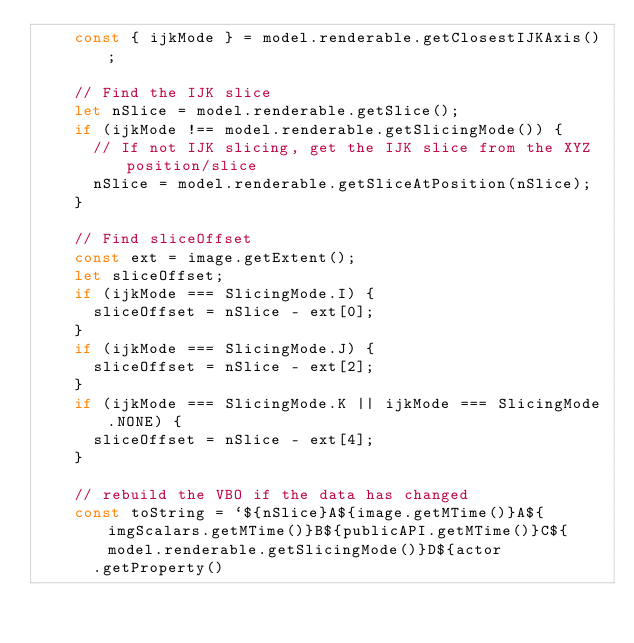<code> <loc_0><loc_0><loc_500><loc_500><_JavaScript_>    const { ijkMode } = model.renderable.getClosestIJKAxis();

    // Find the IJK slice
    let nSlice = model.renderable.getSlice();
    if (ijkMode !== model.renderable.getSlicingMode()) {
      // If not IJK slicing, get the IJK slice from the XYZ position/slice
      nSlice = model.renderable.getSliceAtPosition(nSlice);
    }

    // Find sliceOffset
    const ext = image.getExtent();
    let sliceOffset;
    if (ijkMode === SlicingMode.I) {
      sliceOffset = nSlice - ext[0];
    }
    if (ijkMode === SlicingMode.J) {
      sliceOffset = nSlice - ext[2];
    }
    if (ijkMode === SlicingMode.K || ijkMode === SlicingMode.NONE) {
      sliceOffset = nSlice - ext[4];
    }

    // rebuild the VBO if the data has changed
    const toString = `${nSlice}A${image.getMTime()}A${imgScalars.getMTime()}B${publicAPI.getMTime()}C${model.renderable.getSlicingMode()}D${actor
      .getProperty()</code> 